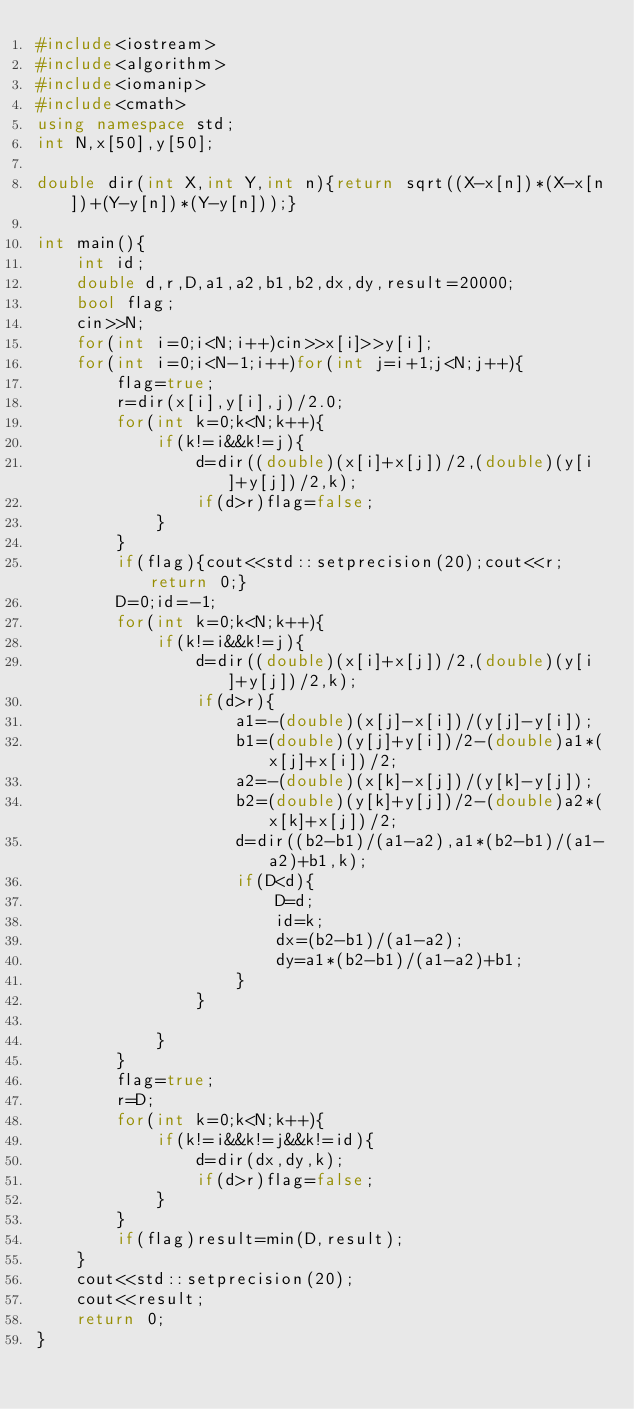<code> <loc_0><loc_0><loc_500><loc_500><_C++_>#include<iostream>
#include<algorithm>
#include<iomanip>
#include<cmath>
using namespace std;
int N,x[50],y[50];

double dir(int X,int Y,int n){return sqrt((X-x[n])*(X-x[n])+(Y-y[n])*(Y-y[n]));}

int main(){
	int id;
	double d,r,D,a1,a2,b1,b2,dx,dy,result=20000;
	bool flag;
	cin>>N;
	for(int i=0;i<N;i++)cin>>x[i]>>y[i];
	for(int i=0;i<N-1;i++)for(int j=i+1;j<N;j++){
		flag=true;
		r=dir(x[i],y[i],j)/2.0;
		for(int k=0;k<N;k++){
			if(k!=i&&k!=j){
				d=dir((double)(x[i]+x[j])/2,(double)(y[i]+y[j])/2,k);
				if(d>r)flag=false;
			}
		}
		if(flag){cout<<std::setprecision(20);cout<<r;return 0;}
		D=0;id=-1;
		for(int k=0;k<N;k++){
			if(k!=i&&k!=j){
				d=dir((double)(x[i]+x[j])/2,(double)(y[i]+y[j])/2,k);
				if(d>r){
					a1=-(double)(x[j]-x[i])/(y[j]-y[i]);
					b1=(double)(y[j]+y[i])/2-(double)a1*(x[j]+x[i])/2;
					a2=-(double)(x[k]-x[j])/(y[k]-y[j]);
					b2=(double)(y[k]+y[j])/2-(double)a2*(x[k]+x[j])/2;
					d=dir((b2-b1)/(a1-a2),a1*(b2-b1)/(a1-a2)+b1,k);
					if(D<d){
						D=d;
						id=k;
						dx=(b2-b1)/(a1-a2);
						dy=a1*(b2-b1)/(a1-a2)+b1;
					}
				}
				
			}
		}
		flag=true;
		r=D;
		for(int k=0;k<N;k++){
			if(k!=i&&k!=j&&k!=id){
				d=dir(dx,dy,k);
				if(d>r)flag=false;
			}
		}
		if(flag)result=min(D,result);
	}
	cout<<std::setprecision(20);
	cout<<result;
	return 0;
}</code> 